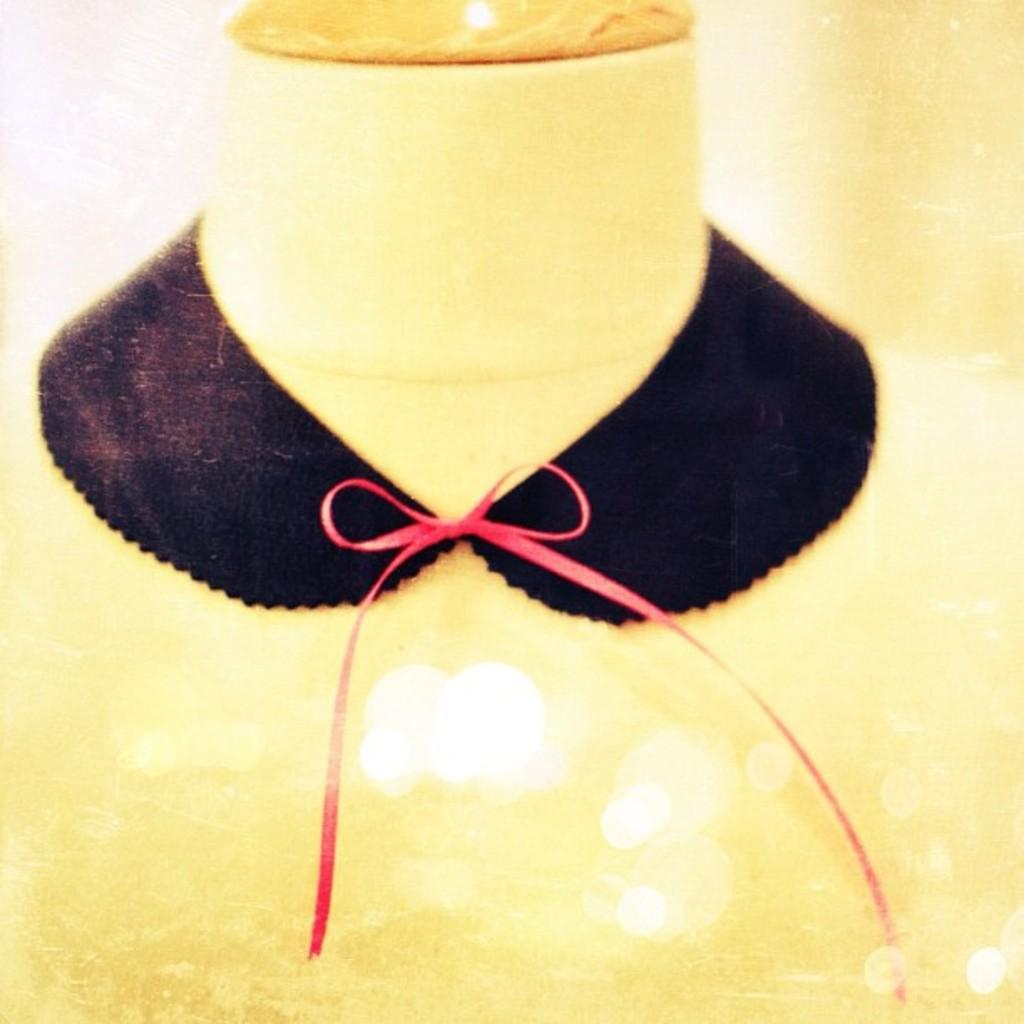What is the main object in the image? There is a neck mannequin in the image. What is covering the neck mannequin? There is a black cloth on the neck mannequin. Are there any additional accessories on the neck mannequin? Yes, there is a ribbon on the neck mannequin. Is there a fan blowing on the neck mannequin in the image? There is no fan present in the image, so it cannot be determined if it is blowing on the neck mannequin. 